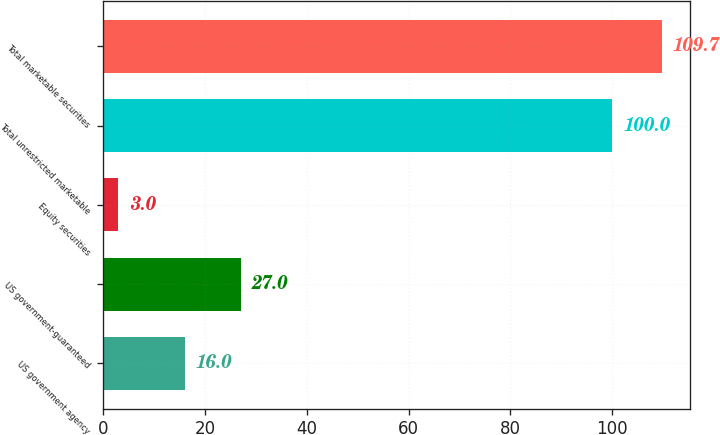<chart> <loc_0><loc_0><loc_500><loc_500><bar_chart><fcel>US government agency<fcel>US government-guaranteed<fcel>Equity securities<fcel>Total unrestricted marketable<fcel>Total marketable securities<nl><fcel>16<fcel>27<fcel>3<fcel>100<fcel>109.7<nl></chart> 